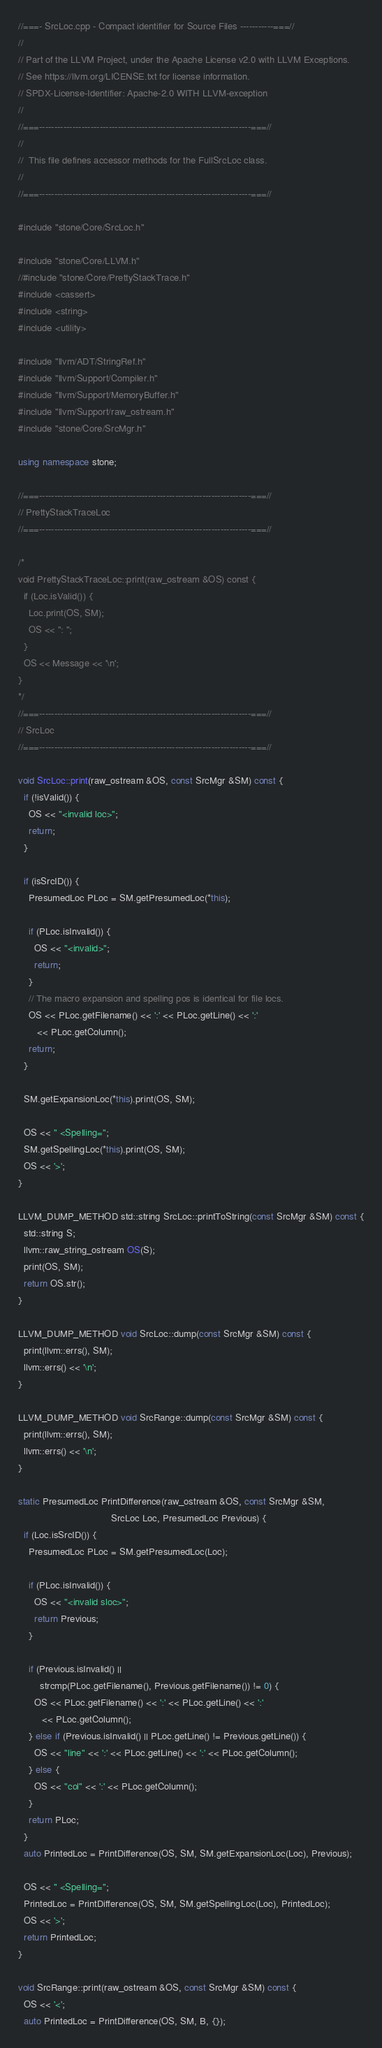<code> <loc_0><loc_0><loc_500><loc_500><_C++_>//===- SrcLoc.cpp - Compact identifier for Source Files -----------===//
//
// Part of the LLVM Project, under the Apache License v2.0 with LLVM Exceptions.
// See https://llvm.org/LICENSE.txt for license information.
// SPDX-License-Identifier: Apache-2.0 WITH LLVM-exception
//
//===----------------------------------------------------------------------===//
//
//  This file defines accessor methods for the FullSrcLoc class.
//
//===----------------------------------------------------------------------===//

#include "stone/Core/SrcLoc.h"

#include "stone/Core/LLVM.h"
//#include "stone/Core/PrettyStackTrace.h"
#include <cassert>
#include <string>
#include <utility>

#include "llvm/ADT/StringRef.h"
#include "llvm/Support/Compiler.h"
#include "llvm/Support/MemoryBuffer.h"
#include "llvm/Support/raw_ostream.h"
#include "stone/Core/SrcMgr.h"

using namespace stone;

//===----------------------------------------------------------------------===//
// PrettyStackTraceLoc
//===----------------------------------------------------------------------===//

/*
void PrettyStackTraceLoc::print(raw_ostream &OS) const {
  if (Loc.isValid()) {
    Loc.print(OS, SM);
    OS << ": ";
  }
  OS << Message << '\n';
}
*/
//===----------------------------------------------------------------------===//
// SrcLoc
//===----------------------------------------------------------------------===//

void SrcLoc::print(raw_ostream &OS, const SrcMgr &SM) const {
  if (!isValid()) {
    OS << "<invalid loc>";
    return;
  }

  if (isSrcID()) {
    PresumedLoc PLoc = SM.getPresumedLoc(*this);

    if (PLoc.isInvalid()) {
      OS << "<invalid>";
      return;
    }
    // The macro expansion and spelling pos is identical for file locs.
    OS << PLoc.getFilename() << ':' << PLoc.getLine() << ':'
       << PLoc.getColumn();
    return;
  }

  SM.getExpansionLoc(*this).print(OS, SM);

  OS << " <Spelling=";
  SM.getSpellingLoc(*this).print(OS, SM);
  OS << '>';
}

LLVM_DUMP_METHOD std::string SrcLoc::printToString(const SrcMgr &SM) const {
  std::string S;
  llvm::raw_string_ostream OS(S);
  print(OS, SM);
  return OS.str();
}

LLVM_DUMP_METHOD void SrcLoc::dump(const SrcMgr &SM) const {
  print(llvm::errs(), SM);
  llvm::errs() << '\n';
}

LLVM_DUMP_METHOD void SrcRange::dump(const SrcMgr &SM) const {
  print(llvm::errs(), SM);
  llvm::errs() << '\n';
}

static PresumedLoc PrintDifference(raw_ostream &OS, const SrcMgr &SM,
                                   SrcLoc Loc, PresumedLoc Previous) {
  if (Loc.isSrcID()) {
    PresumedLoc PLoc = SM.getPresumedLoc(Loc);

    if (PLoc.isInvalid()) {
      OS << "<invalid sloc>";
      return Previous;
    }

    if (Previous.isInvalid() ||
        strcmp(PLoc.getFilename(), Previous.getFilename()) != 0) {
      OS << PLoc.getFilename() << ':' << PLoc.getLine() << ':'
         << PLoc.getColumn();
    } else if (Previous.isInvalid() || PLoc.getLine() != Previous.getLine()) {
      OS << "line" << ':' << PLoc.getLine() << ':' << PLoc.getColumn();
    } else {
      OS << "col" << ':' << PLoc.getColumn();
    }
    return PLoc;
  }
  auto PrintedLoc = PrintDifference(OS, SM, SM.getExpansionLoc(Loc), Previous);

  OS << " <Spelling=";
  PrintedLoc = PrintDifference(OS, SM, SM.getSpellingLoc(Loc), PrintedLoc);
  OS << '>';
  return PrintedLoc;
}

void SrcRange::print(raw_ostream &OS, const SrcMgr &SM) const {
  OS << '<';
  auto PrintedLoc = PrintDifference(OS, SM, B, {});</code> 